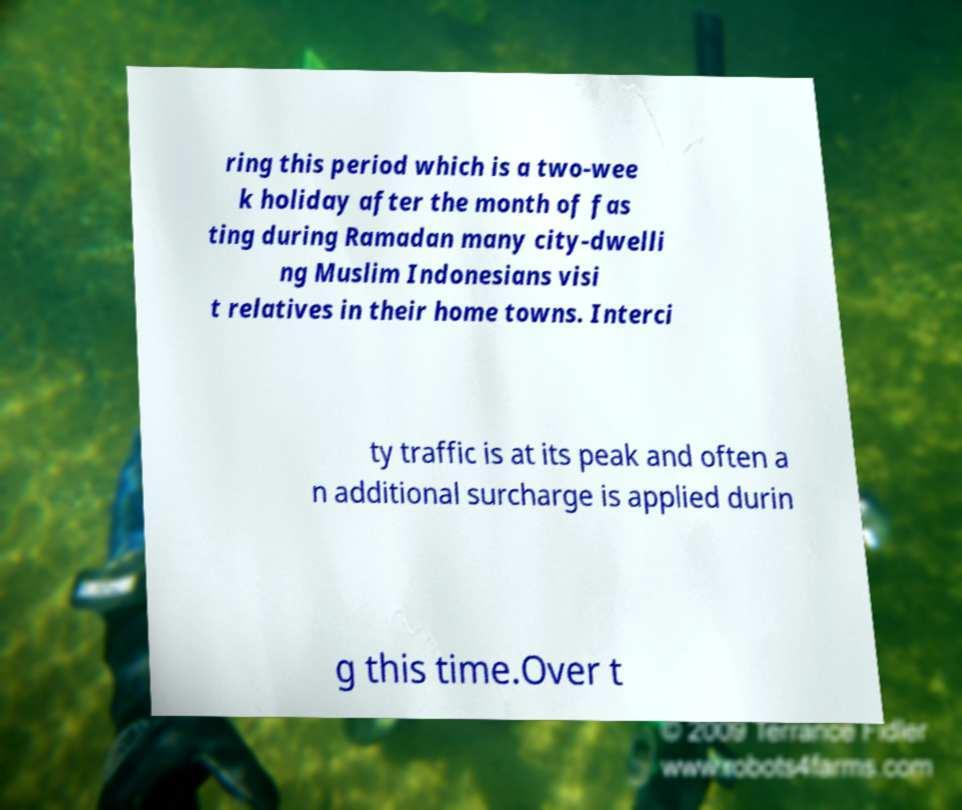Please read and relay the text visible in this image. What does it say? ring this period which is a two-wee k holiday after the month of fas ting during Ramadan many city-dwelli ng Muslim Indonesians visi t relatives in their home towns. Interci ty traffic is at its peak and often a n additional surcharge is applied durin g this time.Over t 